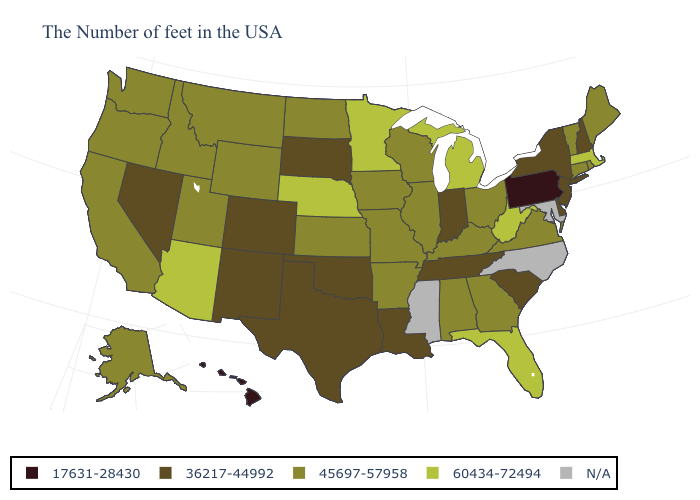What is the value of Wyoming?
Be succinct. 45697-57958. How many symbols are there in the legend?
Short answer required. 5. What is the value of Louisiana?
Give a very brief answer. 36217-44992. Does Minnesota have the highest value in the MidWest?
Quick response, please. Yes. Name the states that have a value in the range 60434-72494?
Give a very brief answer. Massachusetts, West Virginia, Florida, Michigan, Minnesota, Nebraska, Arizona. Does Oregon have the highest value in the West?
Be succinct. No. What is the value of Arizona?
Short answer required. 60434-72494. Among the states that border Indiana , does Michigan have the lowest value?
Answer briefly. No. Among the states that border South Dakota , does Iowa have the highest value?
Short answer required. No. Which states hav the highest value in the MidWest?
Answer briefly. Michigan, Minnesota, Nebraska. Name the states that have a value in the range 45697-57958?
Quick response, please. Maine, Rhode Island, Vermont, Connecticut, Virginia, Ohio, Georgia, Kentucky, Alabama, Wisconsin, Illinois, Missouri, Arkansas, Iowa, Kansas, North Dakota, Wyoming, Utah, Montana, Idaho, California, Washington, Oregon, Alaska. Name the states that have a value in the range 17631-28430?
Keep it brief. Pennsylvania, Hawaii. What is the value of New York?
Answer briefly. 36217-44992. Among the states that border Indiana , does Ohio have the lowest value?
Give a very brief answer. Yes. 